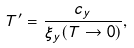<formula> <loc_0><loc_0><loc_500><loc_500>T ^ { \prime } = \frac { c _ { y } } { \xi _ { y } ( T \rightarrow 0 ) } ,</formula> 